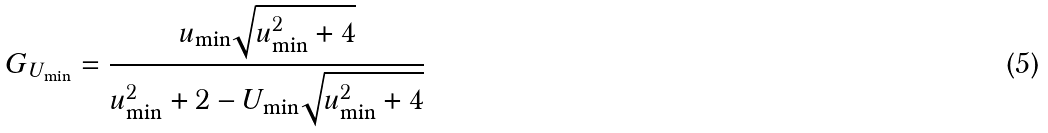Convert formula to latex. <formula><loc_0><loc_0><loc_500><loc_500>G _ { U _ { \min } } = \frac { u _ { \min } \sqrt { u _ { \min } ^ { 2 } + 4 } } { u _ { \min } ^ { 2 } + 2 - U _ { \min } \sqrt { u _ { \min } ^ { 2 } + 4 } }</formula> 